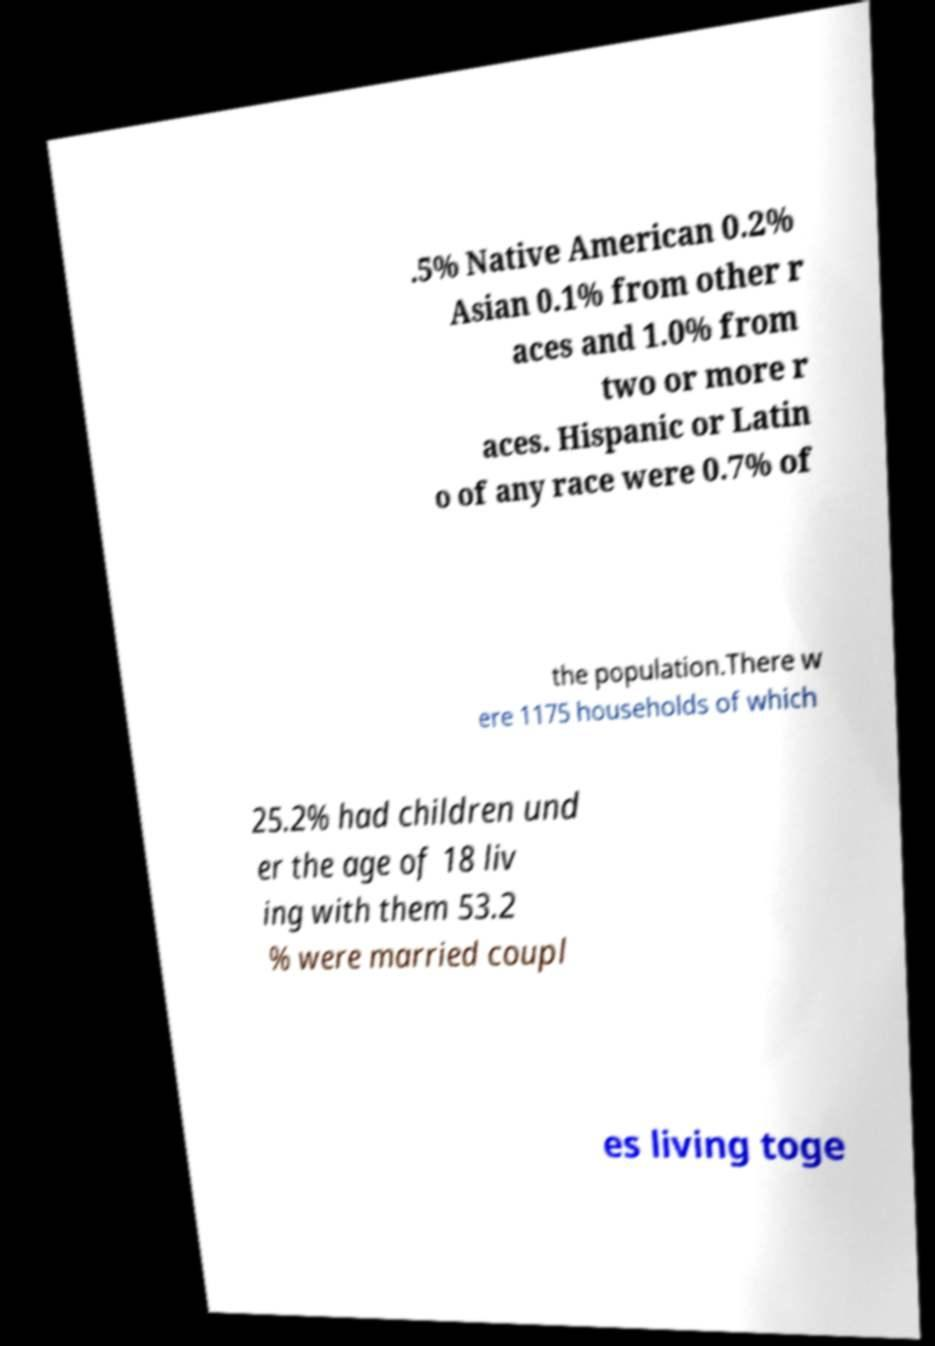Please identify and transcribe the text found in this image. .5% Native American 0.2% Asian 0.1% from other r aces and 1.0% from two or more r aces. Hispanic or Latin o of any race were 0.7% of the population.There w ere 1175 households of which 25.2% had children und er the age of 18 liv ing with them 53.2 % were married coupl es living toge 